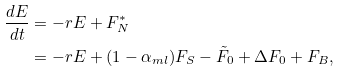Convert formula to latex. <formula><loc_0><loc_0><loc_500><loc_500>\frac { d E } { d t } & = - r E + F ^ { * } _ { N } \\ & = - r E + ( 1 - \alpha _ { m l } ) F _ { S } - \tilde { F } _ { 0 } + \Delta F _ { 0 } + F _ { B } ,</formula> 